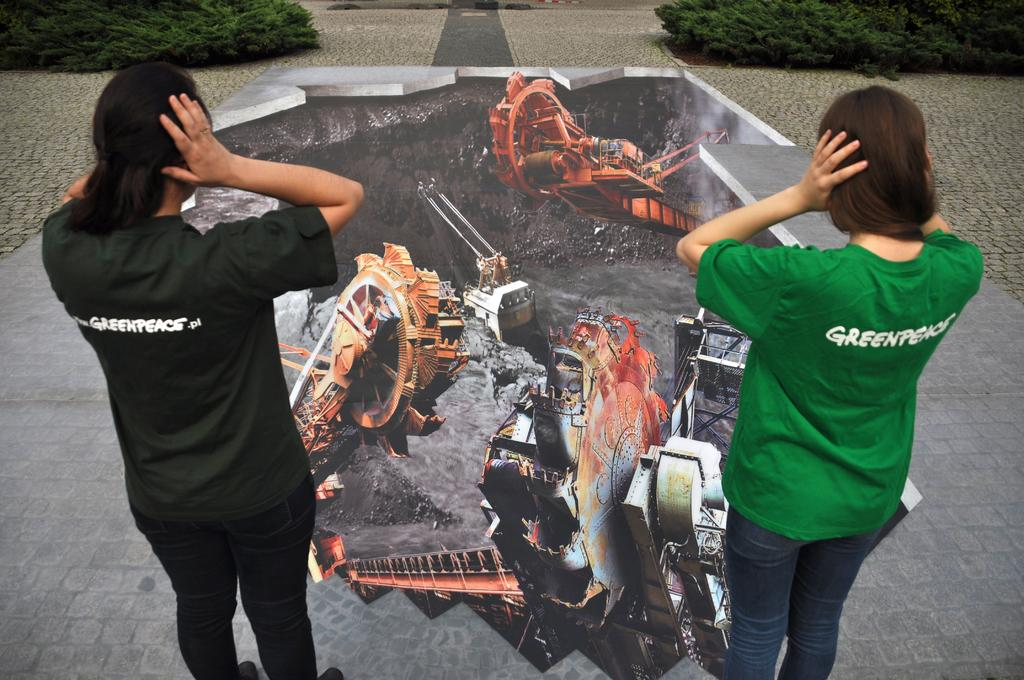<image>
Create a compact narrative representing the image presented. Two women wearing shirts that have Greenpeace on the back 